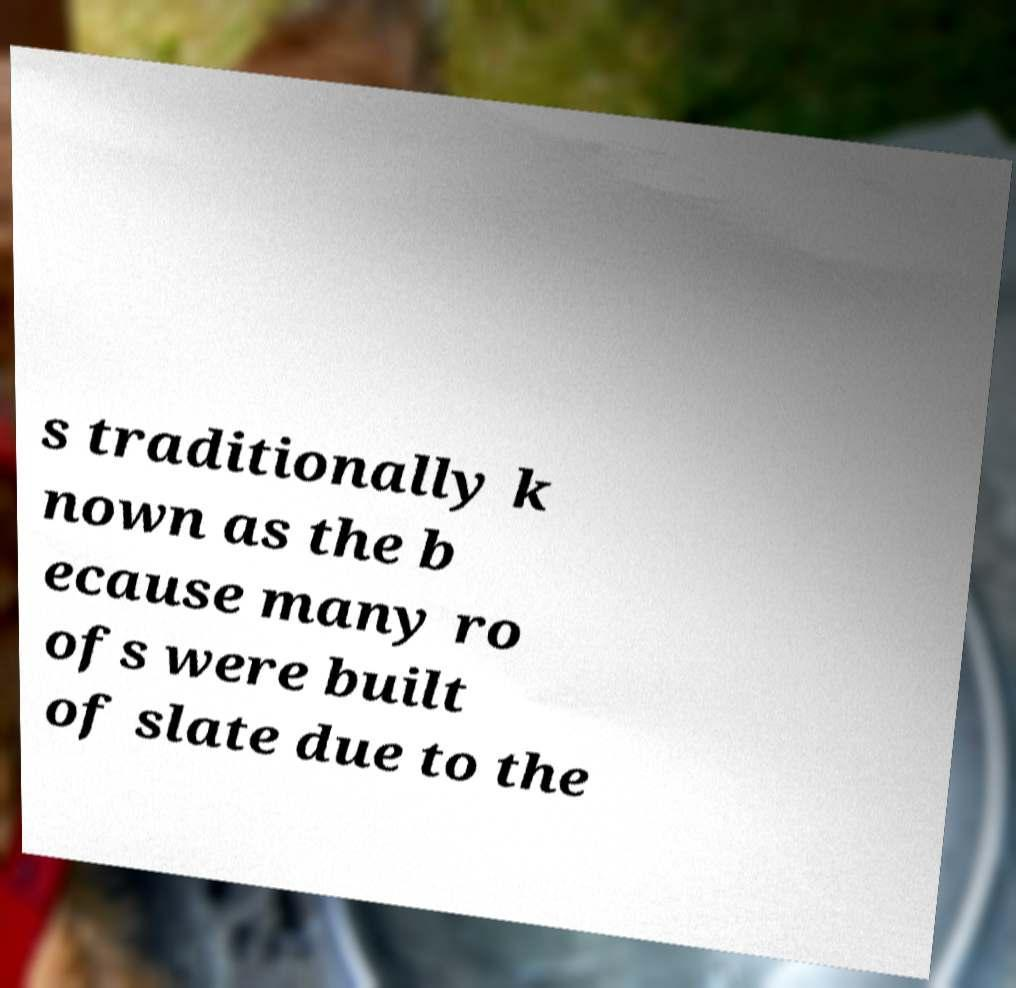Could you assist in decoding the text presented in this image and type it out clearly? s traditionally k nown as the b ecause many ro ofs were built of slate due to the 